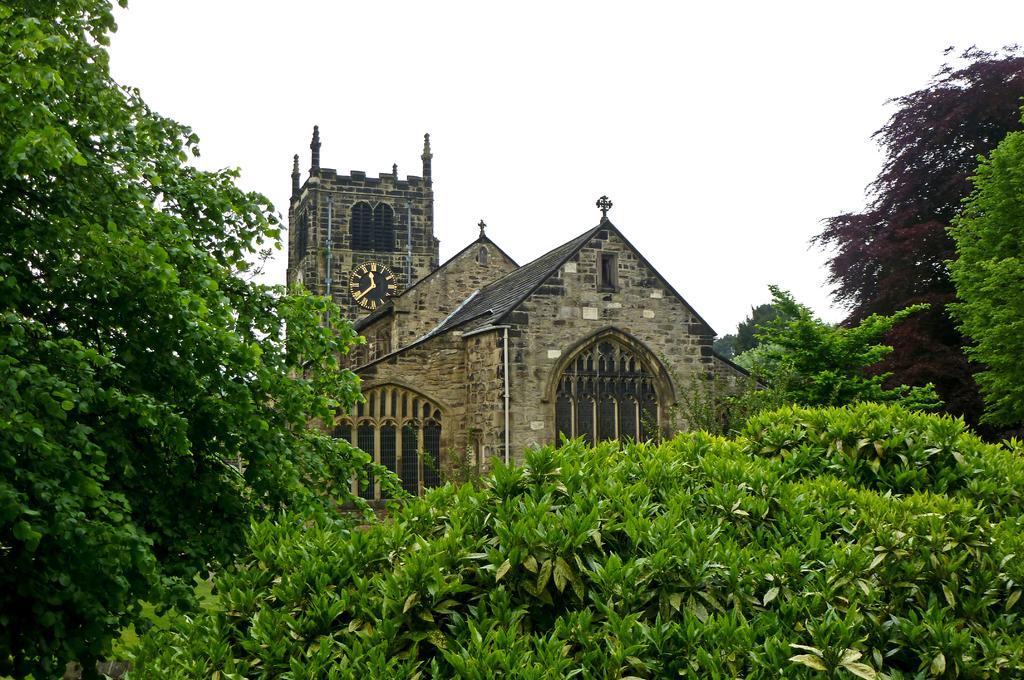In one or two sentences, can you explain what this image depicts? In this picture there is a house in the center of the image, on which there is a clock and there is greenery in the image and there is sky at the top side of the image. 